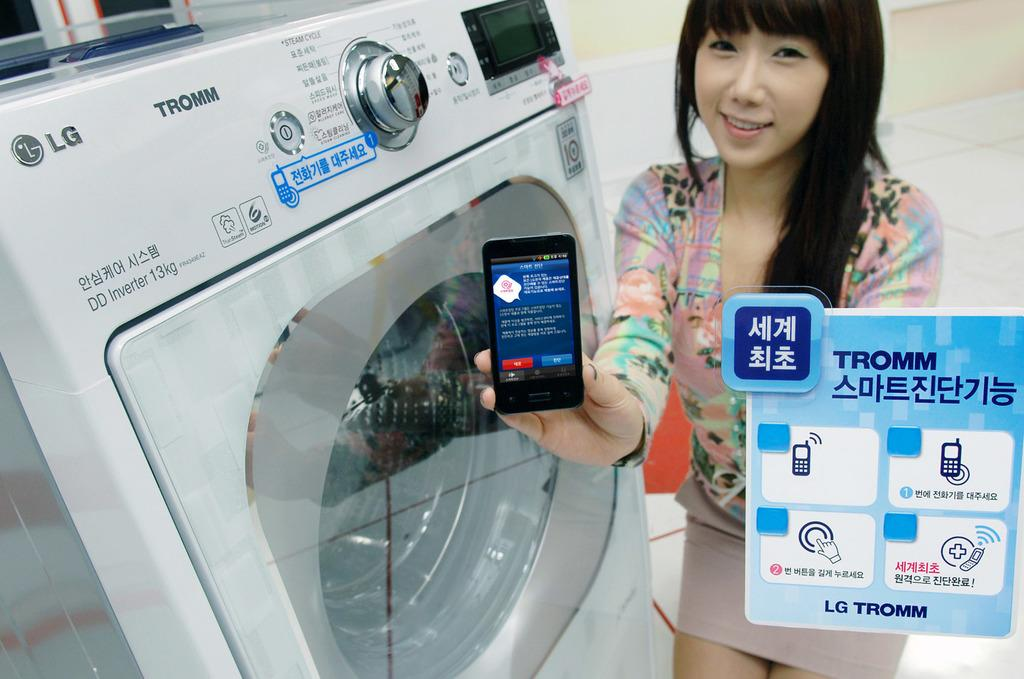<image>
Share a concise interpretation of the image provided. A woman holds a Tromm mobile device near a washing machine. 